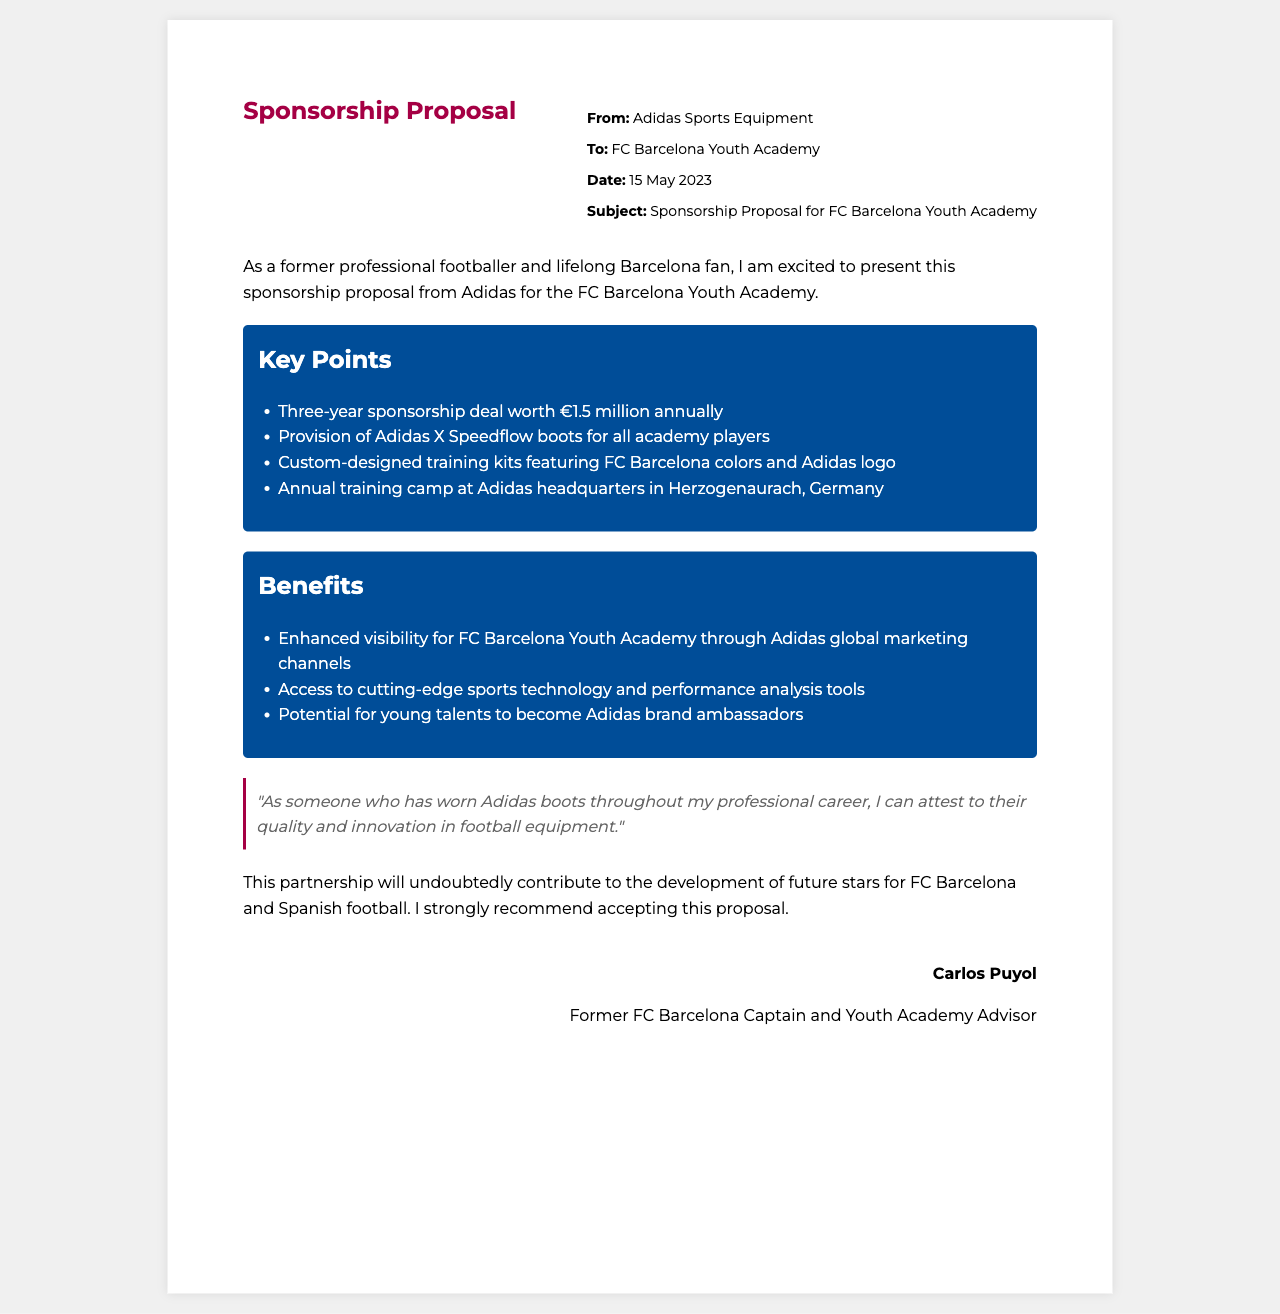What is the annual sponsorship amount? The document states that the sponsorship deal is worth 1.5 million euros annually.
Answer: €1.5 million Who is the sender of the proposal? The proposal is sent by Adidas Sports Equipment.
Answer: Adidas Sports Equipment What is included for all academy players? The proposal includes the provision of Adidas X Speedflow boots.
Answer: Adidas X Speedflow boots What is the duration of the sponsorship deal? The document specifies a three-year sponsorship deal.
Answer: Three years Where is the annual training camp located? The training camp is at Adidas headquarters in Herzogenaurach, Germany.
Answer: Herzogenaurach, Germany What benefit does the partnership provide regarding visibility? The partnership enhances visibility through Adidas global marketing channels.
Answer: Enhanced visibility Who is the author of the testimonial? The testimonial is attributed to Carlos Puyol.
Answer: Carlos Puyol What is the primary objective of the partnership? The partnership aims to contribute to the development of future stars for FC Barcelona and Spanish football.
Answer: Development of future stars What colors are featured in the custom-designed training kits? The training kits feature FC Barcelona colors.
Answer: FC Barcelona colors 